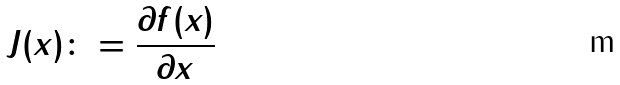Convert formula to latex. <formula><loc_0><loc_0><loc_500><loc_500>J ( x ) \colon = \frac { \partial f ( x ) } { \partial x }</formula> 